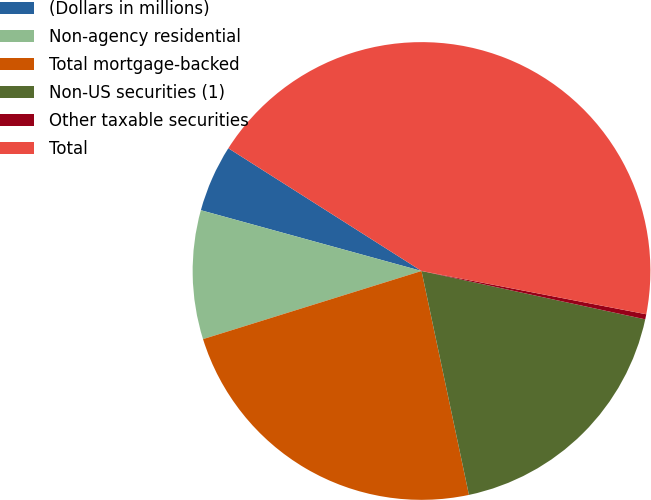Convert chart to OTSL. <chart><loc_0><loc_0><loc_500><loc_500><pie_chart><fcel>(Dollars in millions)<fcel>Non-agency residential<fcel>Total mortgage-backed<fcel>Non-US securities (1)<fcel>Other taxable securities<fcel>Total<nl><fcel>4.73%<fcel>9.09%<fcel>23.51%<fcel>18.29%<fcel>0.36%<fcel>44.02%<nl></chart> 